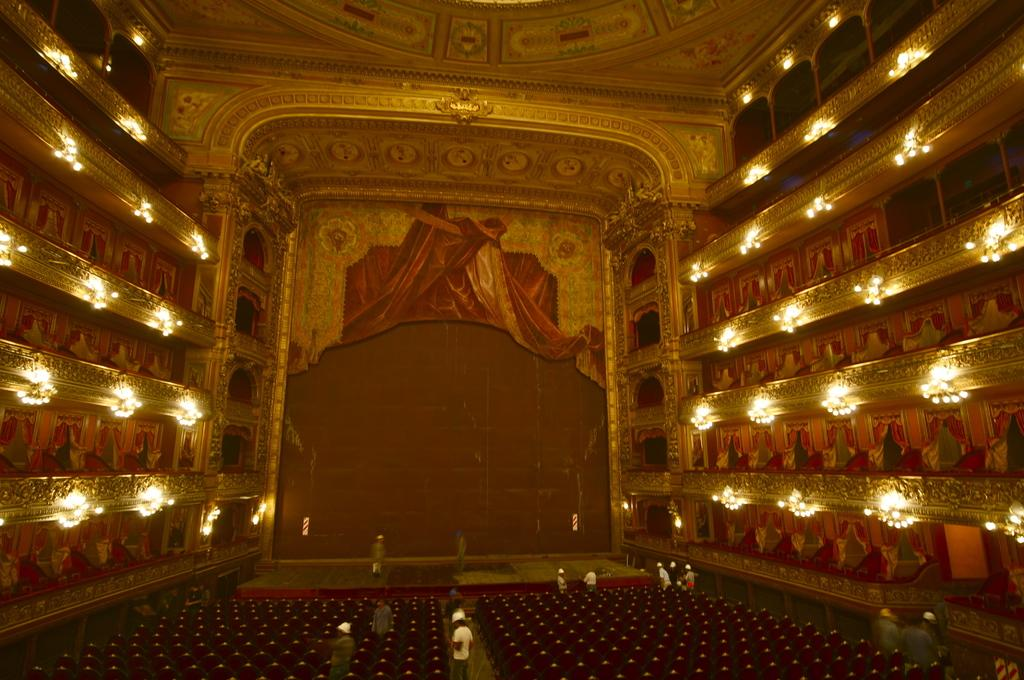What type of setting is depicted in the image? The image shows an interior view of a building. What can be seen on the wall in the image? Lights are visible on the wall. What type of furniture is present in the image? Chairs are present in the image. Can you describe the person visible in the image? A person is visible at the bottom of the image. What color is the grape that the person is holding in the image? There is no grape present in the image, and the person is not holding anything. How many bulbs are visible on the wall in the image? The provided facts do not specify the number of bulbs on the wall, only that lights are visible. 